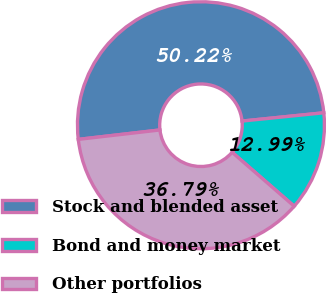<chart> <loc_0><loc_0><loc_500><loc_500><pie_chart><fcel>Stock and blended asset<fcel>Bond and money market<fcel>Other portfolios<nl><fcel>50.22%<fcel>12.99%<fcel>36.79%<nl></chart> 